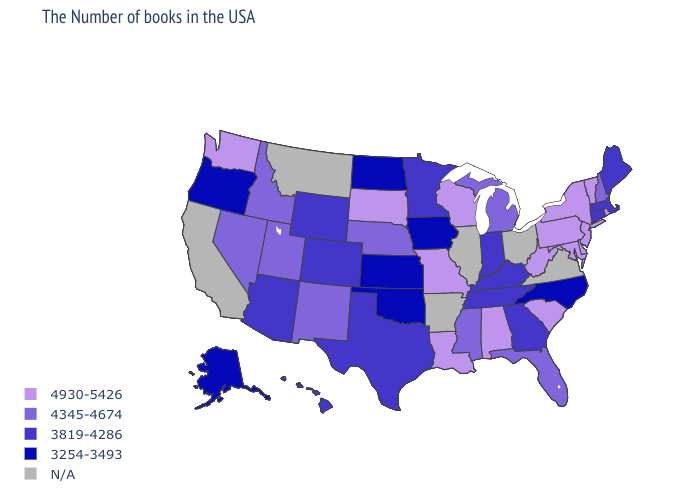What is the value of North Dakota?
Write a very short answer. 3254-3493. Name the states that have a value in the range 3254-3493?
Short answer required. North Carolina, Iowa, Kansas, Oklahoma, North Dakota, Oregon, Alaska. Does the map have missing data?
Give a very brief answer. Yes. Is the legend a continuous bar?
Short answer required. No. What is the lowest value in the MidWest?
Be succinct. 3254-3493. Does the first symbol in the legend represent the smallest category?
Concise answer only. No. What is the lowest value in states that border Nevada?
Write a very short answer. 3254-3493. Name the states that have a value in the range N/A?
Short answer required. Virginia, Ohio, Illinois, Arkansas, Montana, California. What is the value of Alaska?
Concise answer only. 3254-3493. What is the highest value in the USA?
Be succinct. 4930-5426. Does Nevada have the highest value in the USA?
Be succinct. No. Name the states that have a value in the range N/A?
Answer briefly. Virginia, Ohio, Illinois, Arkansas, Montana, California. What is the highest value in the Northeast ?
Give a very brief answer. 4930-5426. Name the states that have a value in the range 4345-4674?
Be succinct. New Hampshire, Florida, Michigan, Mississippi, Nebraska, New Mexico, Utah, Idaho, Nevada. 